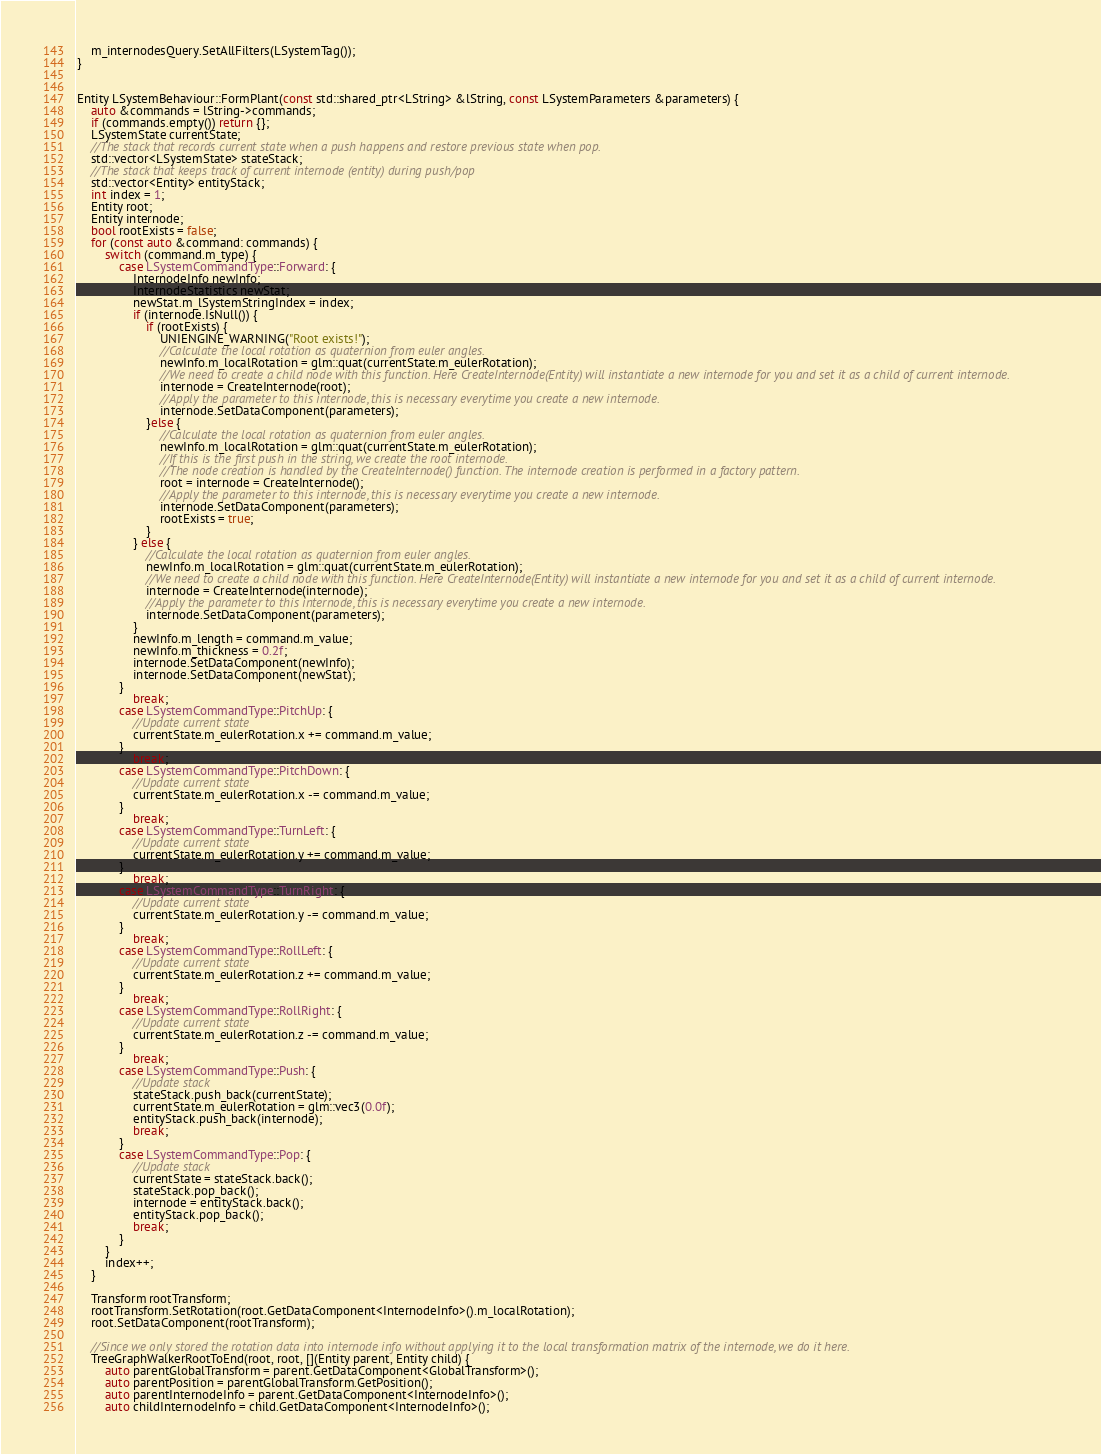Convert code to text. <code><loc_0><loc_0><loc_500><loc_500><_C++_>    m_internodesQuery.SetAllFilters(LSystemTag());
}


Entity LSystemBehaviour::FormPlant(const std::shared_ptr<LString> &lString, const LSystemParameters &parameters) {
    auto &commands = lString->commands;
    if (commands.empty()) return {};
    LSystemState currentState;
    //The stack that records current state when a push happens and restore previous state when pop.
    std::vector<LSystemState> stateStack;
    //The stack that keeps track of current internode (entity) during push/pop
    std::vector<Entity> entityStack;
    int index = 1;
    Entity root;
    Entity internode;
    bool rootExists = false;
    for (const auto &command: commands) {
        switch (command.m_type) {
            case LSystemCommandType::Forward: {
                InternodeInfo newInfo;
                InternodeStatistics newStat;
                newStat.m_lSystemStringIndex = index;
                if (internode.IsNull()) {
                    if (rootExists) {
                        UNIENGINE_WARNING("Root exists!");
                        //Calculate the local rotation as quaternion from euler angles.
                        newInfo.m_localRotation = glm::quat(currentState.m_eulerRotation);
                        //We need to create a child node with this function. Here CreateInternode(Entity) will instantiate a new internode for you and set it as a child of current internode.
                        internode = CreateInternode(root);
                        //Apply the parameter to this internode, this is necessary everytime you create a new internode.
                        internode.SetDataComponent(parameters);
                    }else {
                        //Calculate the local rotation as quaternion from euler angles.
                        newInfo.m_localRotation = glm::quat(currentState.m_eulerRotation);
                        //If this is the first push in the string, we create the root internode.
                        //The node creation is handled by the CreateInternode() function. The internode creation is performed in a factory pattern.
                        root = internode = CreateInternode();
                        //Apply the parameter to this internode, this is necessary everytime you create a new internode.
                        internode.SetDataComponent(parameters);
                        rootExists = true;
                    }
                } else {
                    //Calculate the local rotation as quaternion from euler angles.
                    newInfo.m_localRotation = glm::quat(currentState.m_eulerRotation);
                    //We need to create a child node with this function. Here CreateInternode(Entity) will instantiate a new internode for you and set it as a child of current internode.
                    internode = CreateInternode(internode);
                    //Apply the parameter to this internode, this is necessary everytime you create a new internode.
                    internode.SetDataComponent(parameters);
                }
                newInfo.m_length = command.m_value;
                newInfo.m_thickness = 0.2f;
                internode.SetDataComponent(newInfo);
                internode.SetDataComponent(newStat);
            }
                break;
            case LSystemCommandType::PitchUp: {
                //Update current state
                currentState.m_eulerRotation.x += command.m_value;
            }
                break;
            case LSystemCommandType::PitchDown: {
                //Update current state
                currentState.m_eulerRotation.x -= command.m_value;
            }
                break;
            case LSystemCommandType::TurnLeft: {
                //Update current state
                currentState.m_eulerRotation.y += command.m_value;
            }
                break;
            case LSystemCommandType::TurnRight: {
                //Update current state
                currentState.m_eulerRotation.y -= command.m_value;
            }
                break;
            case LSystemCommandType::RollLeft: {
                //Update current state
                currentState.m_eulerRotation.z += command.m_value;
            }
                break;
            case LSystemCommandType::RollRight: {
                //Update current state
                currentState.m_eulerRotation.z -= command.m_value;
            }
                break;
            case LSystemCommandType::Push: {
                //Update stack
                stateStack.push_back(currentState);
                currentState.m_eulerRotation = glm::vec3(0.0f);
                entityStack.push_back(internode);
                break;
            }
            case LSystemCommandType::Pop: {
                //Update stack
                currentState = stateStack.back();
                stateStack.pop_back();
                internode = entityStack.back();
                entityStack.pop_back();
                break;
            }
        }
        index++;
    }

    Transform rootTransform;
    rootTransform.SetRotation(root.GetDataComponent<InternodeInfo>().m_localRotation);
    root.SetDataComponent(rootTransform);

    //Since we only stored the rotation data into internode info without applying it to the local transformation matrix of the internode, we do it here.
    TreeGraphWalkerRootToEnd(root, root, [](Entity parent, Entity child) {
        auto parentGlobalTransform = parent.GetDataComponent<GlobalTransform>();
        auto parentPosition = parentGlobalTransform.GetPosition();
        auto parentInternodeInfo = parent.GetDataComponent<InternodeInfo>();
        auto childInternodeInfo = child.GetDataComponent<InternodeInfo>();</code> 